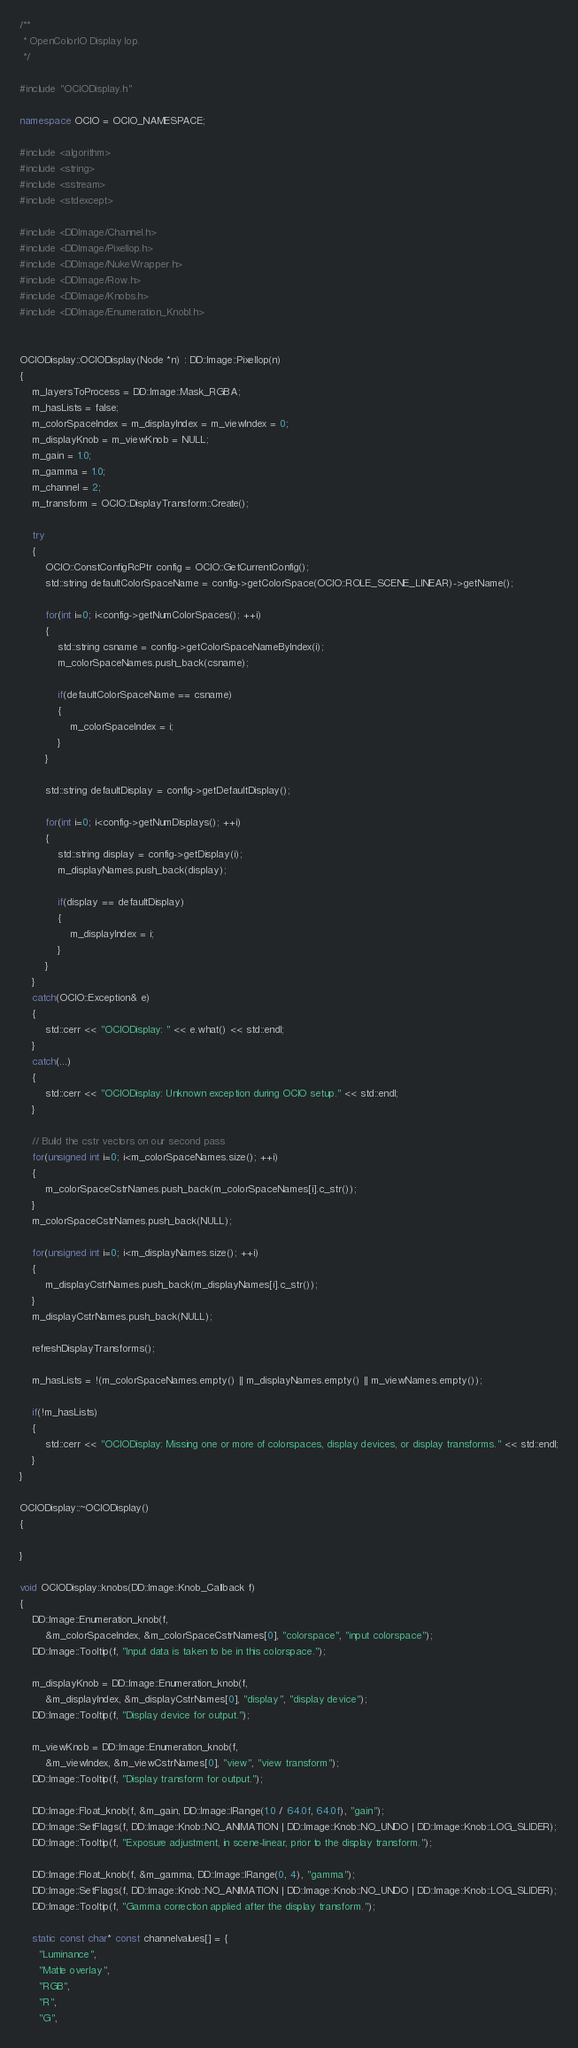<code> <loc_0><loc_0><loc_500><loc_500><_C++_>/**
 * OpenColorIO Display Iop.
 */

#include "OCIODisplay.h"

namespace OCIO = OCIO_NAMESPACE;

#include <algorithm>
#include <string>
#include <sstream>
#include <stdexcept>

#include <DDImage/Channel.h>
#include <DDImage/PixelIop.h>
#include <DDImage/NukeWrapper.h>
#include <DDImage/Row.h>
#include <DDImage/Knobs.h>
#include <DDImage/Enumeration_KnobI.h>


OCIODisplay::OCIODisplay(Node *n) : DD::Image::PixelIop(n)
{
    m_layersToProcess = DD::Image::Mask_RGBA;
    m_hasLists = false;
    m_colorSpaceIndex = m_displayIndex = m_viewIndex = 0;
    m_displayKnob = m_viewKnob = NULL;
    m_gain = 1.0;
    m_gamma = 1.0;
    m_channel = 2;
    m_transform = OCIO::DisplayTransform::Create();
    
    try
    {
        OCIO::ConstConfigRcPtr config = OCIO::GetCurrentConfig();
        std::string defaultColorSpaceName = config->getColorSpace(OCIO::ROLE_SCENE_LINEAR)->getName();
        
        for(int i=0; i<config->getNumColorSpaces(); ++i)
        {
            std::string csname = config->getColorSpaceNameByIndex(i);
            m_colorSpaceNames.push_back(csname);
            
            if(defaultColorSpaceName == csname)
            {
                m_colorSpaceIndex = i;
            }
        }
        
        std::string defaultDisplay = config->getDefaultDisplay();
        
        for(int i=0; i<config->getNumDisplays(); ++i)
        {
            std::string display = config->getDisplay(i);
            m_displayNames.push_back(display);
            
            if(display == defaultDisplay)
            {
                m_displayIndex = i;
            }
        }
    }
    catch(OCIO::Exception& e)
    {
        std::cerr << "OCIODisplay: " << e.what() << std::endl;
    }
    catch(...)
    {
        std::cerr << "OCIODisplay: Unknown exception during OCIO setup." << std::endl;
    }
    
    // Build the cstr vectors on our second pass
    for(unsigned int i=0; i<m_colorSpaceNames.size(); ++i)
    {
        m_colorSpaceCstrNames.push_back(m_colorSpaceNames[i].c_str());
    }
    m_colorSpaceCstrNames.push_back(NULL);
    
    for(unsigned int i=0; i<m_displayNames.size(); ++i)
    {
        m_displayCstrNames.push_back(m_displayNames[i].c_str());
    }
    m_displayCstrNames.push_back(NULL);
    
    refreshDisplayTransforms();
    
    m_hasLists = !(m_colorSpaceNames.empty() || m_displayNames.empty() || m_viewNames.empty());
    
    if(!m_hasLists)
    {
        std::cerr << "OCIODisplay: Missing one or more of colorspaces, display devices, or display transforms." << std::endl;
    }
}

OCIODisplay::~OCIODisplay()
{

}

void OCIODisplay::knobs(DD::Image::Knob_Callback f)
{
    DD::Image::Enumeration_knob(f,
        &m_colorSpaceIndex, &m_colorSpaceCstrNames[0], "colorspace", "input colorspace");
    DD::Image::Tooltip(f, "Input data is taken to be in this colorspace.");

    m_displayKnob = DD::Image::Enumeration_knob(f,
        &m_displayIndex, &m_displayCstrNames[0], "display", "display device");
    DD::Image::Tooltip(f, "Display device for output.");

    m_viewKnob = DD::Image::Enumeration_knob(f,
        &m_viewIndex, &m_viewCstrNames[0], "view", "view transform");
    DD::Image::Tooltip(f, "Display transform for output.");
    
    DD::Image::Float_knob(f, &m_gain, DD::Image::IRange(1.0 / 64.0f, 64.0f), "gain");
    DD::Image::SetFlags(f, DD::Image::Knob::NO_ANIMATION | DD::Image::Knob::NO_UNDO | DD::Image::Knob::LOG_SLIDER);
    DD::Image::Tooltip(f, "Exposure adjustment, in scene-linear, prior to the display transform.");
    
    DD::Image::Float_knob(f, &m_gamma, DD::Image::IRange(0, 4), "gamma");
    DD::Image::SetFlags(f, DD::Image::Knob::NO_ANIMATION | DD::Image::Knob::NO_UNDO | DD::Image::Knob::LOG_SLIDER);
    DD::Image::Tooltip(f, "Gamma correction applied after the display transform.");
    
    static const char* const channelvalues[] = {
      "Luminance",
      "Matte overlay",
      "RGB",
      "R",
      "G",</code> 